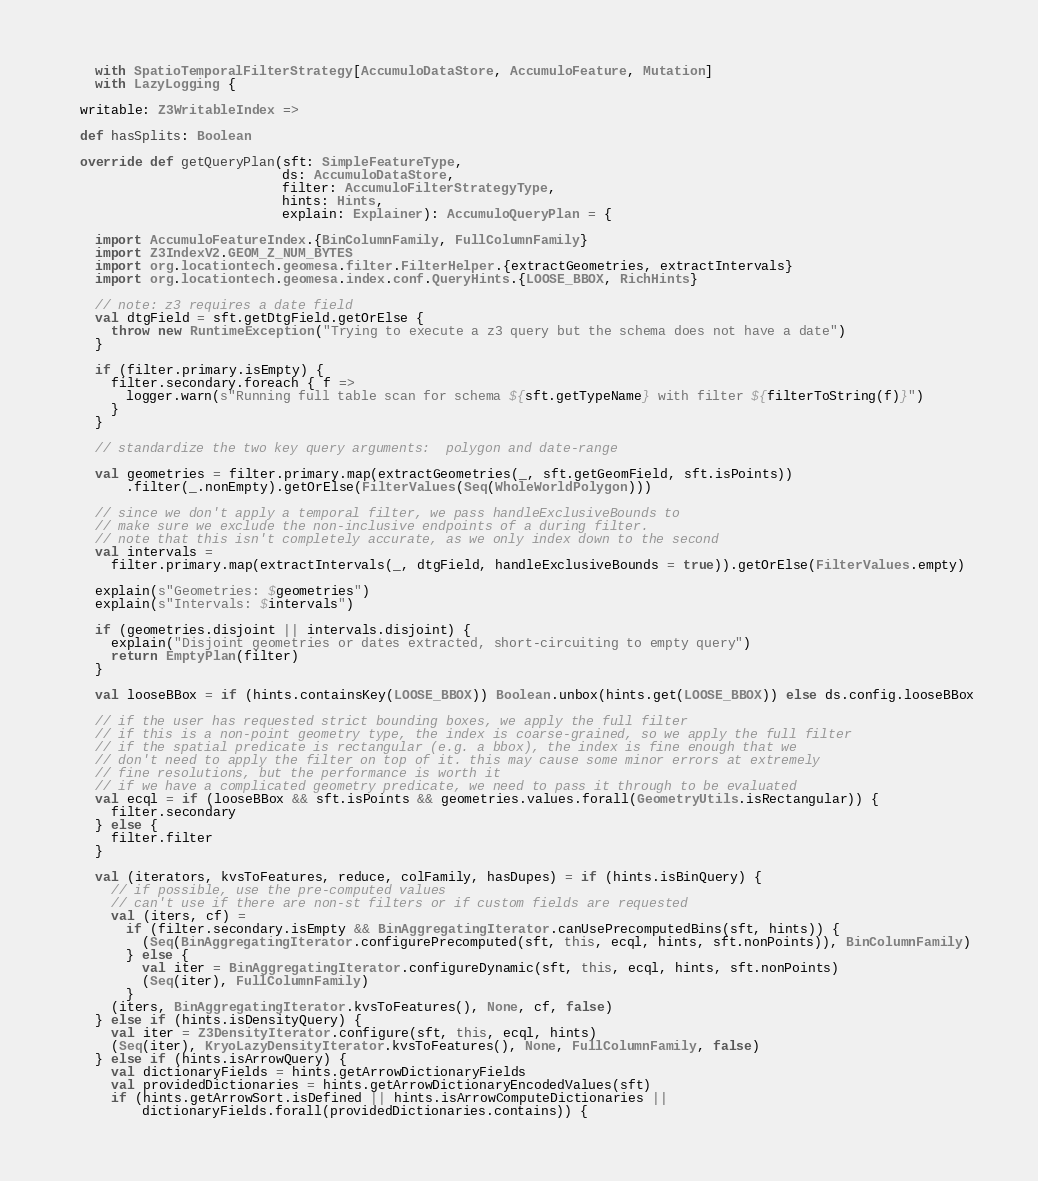<code> <loc_0><loc_0><loc_500><loc_500><_Scala_>    with SpatioTemporalFilterStrategy[AccumuloDataStore, AccumuloFeature, Mutation]
    with LazyLogging {

  writable: Z3WritableIndex =>

  def hasSplits: Boolean

  override def getQueryPlan(sft: SimpleFeatureType,
                            ds: AccumuloDataStore,
                            filter: AccumuloFilterStrategyType,
                            hints: Hints,
                            explain: Explainer): AccumuloQueryPlan = {

    import AccumuloFeatureIndex.{BinColumnFamily, FullColumnFamily}
    import Z3IndexV2.GEOM_Z_NUM_BYTES
    import org.locationtech.geomesa.filter.FilterHelper.{extractGeometries, extractIntervals}
    import org.locationtech.geomesa.index.conf.QueryHints.{LOOSE_BBOX, RichHints}

    // note: z3 requires a date field
    val dtgField = sft.getDtgField.getOrElse {
      throw new RuntimeException("Trying to execute a z3 query but the schema does not have a date")
    }

    if (filter.primary.isEmpty) {
      filter.secondary.foreach { f =>
        logger.warn(s"Running full table scan for schema ${sft.getTypeName} with filter ${filterToString(f)}")
      }
    }

    // standardize the two key query arguments:  polygon and date-range

    val geometries = filter.primary.map(extractGeometries(_, sft.getGeomField, sft.isPoints))
        .filter(_.nonEmpty).getOrElse(FilterValues(Seq(WholeWorldPolygon)))

    // since we don't apply a temporal filter, we pass handleExclusiveBounds to
    // make sure we exclude the non-inclusive endpoints of a during filter.
    // note that this isn't completely accurate, as we only index down to the second
    val intervals =
      filter.primary.map(extractIntervals(_, dtgField, handleExclusiveBounds = true)).getOrElse(FilterValues.empty)

    explain(s"Geometries: $geometries")
    explain(s"Intervals: $intervals")

    if (geometries.disjoint || intervals.disjoint) {
      explain("Disjoint geometries or dates extracted, short-circuiting to empty query")
      return EmptyPlan(filter)
    }

    val looseBBox = if (hints.containsKey(LOOSE_BBOX)) Boolean.unbox(hints.get(LOOSE_BBOX)) else ds.config.looseBBox

    // if the user has requested strict bounding boxes, we apply the full filter
    // if this is a non-point geometry type, the index is coarse-grained, so we apply the full filter
    // if the spatial predicate is rectangular (e.g. a bbox), the index is fine enough that we
    // don't need to apply the filter on top of it. this may cause some minor errors at extremely
    // fine resolutions, but the performance is worth it
    // if we have a complicated geometry predicate, we need to pass it through to be evaluated
    val ecql = if (looseBBox && sft.isPoints && geometries.values.forall(GeometryUtils.isRectangular)) {
      filter.secondary
    } else {
      filter.filter
    }

    val (iterators, kvsToFeatures, reduce, colFamily, hasDupes) = if (hints.isBinQuery) {
      // if possible, use the pre-computed values
      // can't use if there are non-st filters or if custom fields are requested
      val (iters, cf) =
        if (filter.secondary.isEmpty && BinAggregatingIterator.canUsePrecomputedBins(sft, hints)) {
          (Seq(BinAggregatingIterator.configurePrecomputed(sft, this, ecql, hints, sft.nonPoints)), BinColumnFamily)
        } else {
          val iter = BinAggregatingIterator.configureDynamic(sft, this, ecql, hints, sft.nonPoints)
          (Seq(iter), FullColumnFamily)
        }
      (iters, BinAggregatingIterator.kvsToFeatures(), None, cf, false)
    } else if (hints.isDensityQuery) {
      val iter = Z3DensityIterator.configure(sft, this, ecql, hints)
      (Seq(iter), KryoLazyDensityIterator.kvsToFeatures(), None, FullColumnFamily, false)
    } else if (hints.isArrowQuery) {
      val dictionaryFields = hints.getArrowDictionaryFields
      val providedDictionaries = hints.getArrowDictionaryEncodedValues(sft)
      if (hints.getArrowSort.isDefined || hints.isArrowComputeDictionaries ||
          dictionaryFields.forall(providedDictionaries.contains)) {</code> 